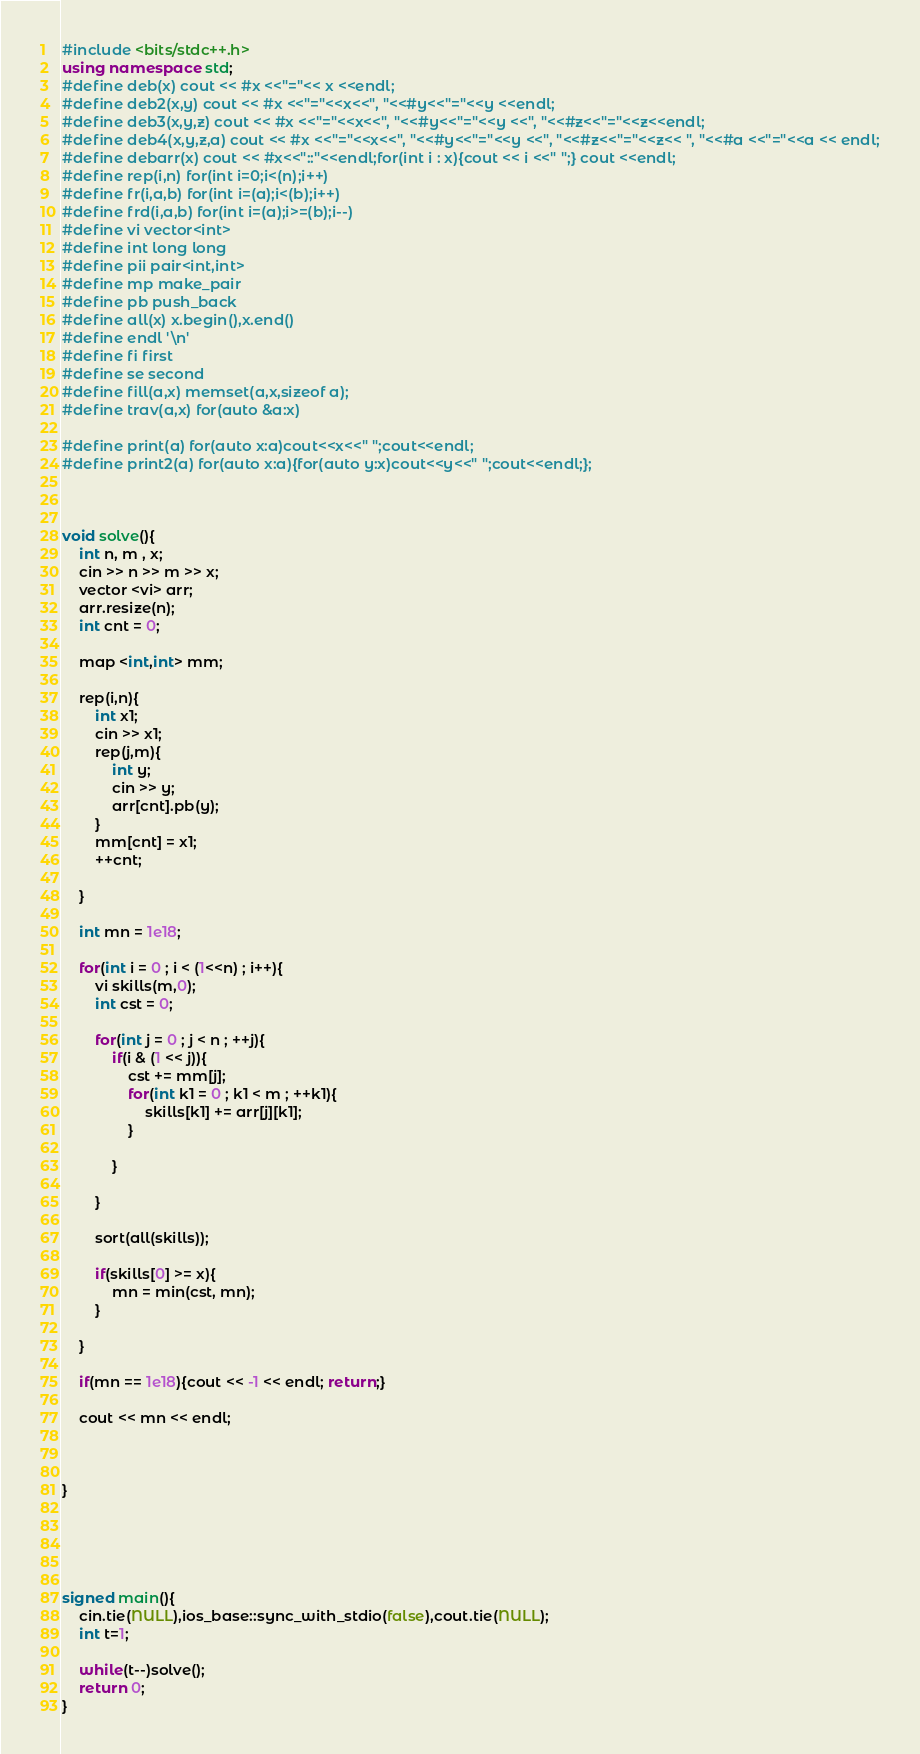<code> <loc_0><loc_0><loc_500><loc_500><_C++_>#include <bits/stdc++.h>
using namespace std; 
#define deb(x) cout << #x <<"="<< x <<endl;
#define deb2(x,y) cout << #x <<"="<<x<<", "<<#y<<"="<<y <<endl;
#define deb3(x,y,z) cout << #x <<"="<<x<<", "<<#y<<"="<<y <<", "<<#z<<"="<<z<<endl;
#define deb4(x,y,z,a) cout << #x <<"="<<x<<", "<<#y<<"="<<y <<", "<<#z<<"="<<z<< ", "<<#a <<"="<<a << endl;
#define debarr(x) cout << #x<<"::"<<endl;for(int i : x){cout << i <<" ";} cout <<endl;
#define rep(i,n) for(int i=0;i<(n);i++)
#define fr(i,a,b) for(int i=(a);i<(b);i++)
#define frd(i,a,b) for(int i=(a);i>=(b);i--)
#define vi vector<int>
#define int long long
#define pii pair<int,int>
#define mp make_pair
#define pb push_back
#define all(x) x.begin(),x.end()
#define endl '\n'
#define fi first
#define se second
#define fill(a,x) memset(a,x,sizeof a);
#define trav(a,x) for(auto &a:x)

#define print(a) for(auto x:a)cout<<x<<" ";cout<<endl;
#define print2(a) for(auto x:a){for(auto y:x)cout<<y<<" ";cout<<endl;}; 



void solve(){
	int n, m , x;
	cin >> n >> m >> x;
	vector <vi> arr;
	arr.resize(n);
	int cnt = 0;
	
	map <int,int> mm;
	
	rep(i,n){
		int x1;
		cin >> x1;
		rep(j,m){
			int y;
			cin >> y;
			arr[cnt].pb(y);
		}
		mm[cnt] = x1;
		++cnt;
		
	}
	
	int mn = 1e18;
	
	for(int i = 0 ; i < (1<<n) ; i++){
		vi skills(m,0);
		int cst = 0;
		
		for(int j = 0 ; j < n ; ++j){
			if(i & (1 << j)){
				cst += mm[j];
				for(int k1 = 0 ; k1 < m ; ++k1){
					skills[k1] += arr[j][k1];
				}
				
			}
			
		}
		
		sort(all(skills));
		
		if(skills[0] >= x){
			mn = min(cst, mn);
		} 
		
	}
	
	if(mn == 1e18){cout << -1 << endl; return;}
	
	cout << mn << endl;



}





signed main(){
    cin.tie(NULL),ios_base::sync_with_stdio(false),cout.tie(NULL);
    int t=1;

    while(t--)solve();
    return 0;
}

</code> 